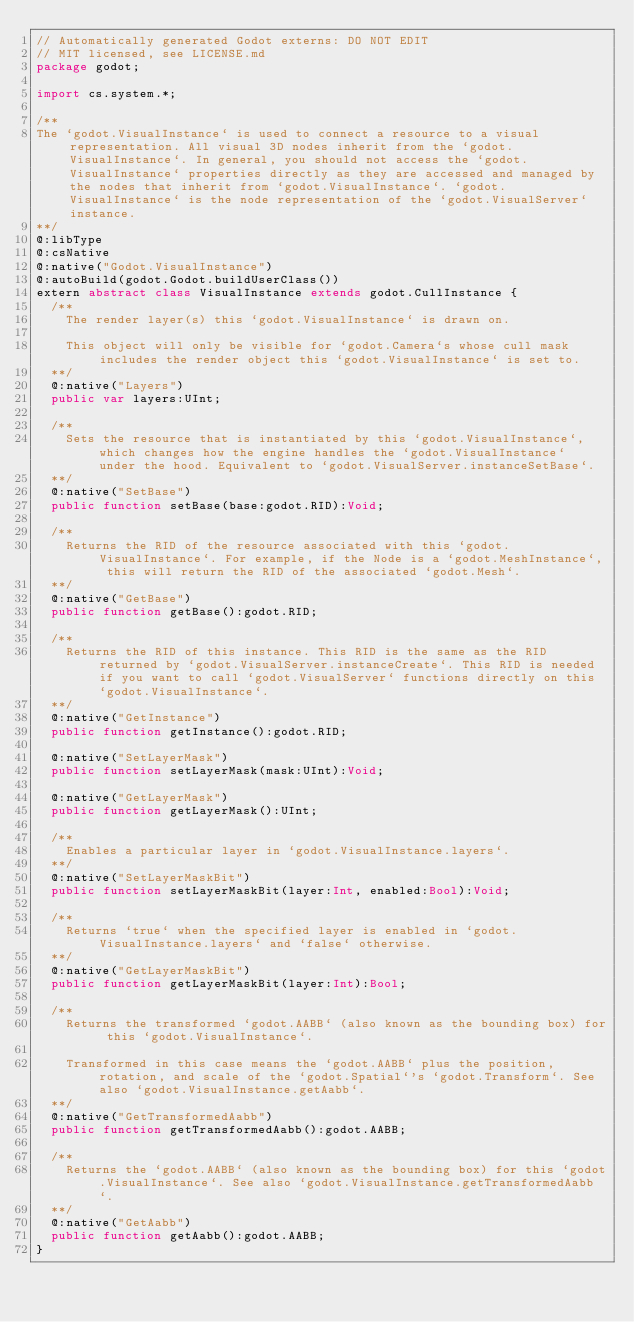Convert code to text. <code><loc_0><loc_0><loc_500><loc_500><_Haxe_>// Automatically generated Godot externs: DO NOT EDIT
// MIT licensed, see LICENSE.md
package godot;

import cs.system.*;

/**
The `godot.VisualInstance` is used to connect a resource to a visual representation. All visual 3D nodes inherit from the `godot.VisualInstance`. In general, you should not access the `godot.VisualInstance` properties directly as they are accessed and managed by the nodes that inherit from `godot.VisualInstance`. `godot.VisualInstance` is the node representation of the `godot.VisualServer` instance.
**/
@:libType
@:csNative
@:native("Godot.VisualInstance")
@:autoBuild(godot.Godot.buildUserClass())
extern abstract class VisualInstance extends godot.CullInstance {
	/**		
		The render layer(s) this `godot.VisualInstance` is drawn on.
		
		This object will only be visible for `godot.Camera`s whose cull mask includes the render object this `godot.VisualInstance` is set to.
	**/
	@:native("Layers")
	public var layers:UInt;

	/**		
		Sets the resource that is instantiated by this `godot.VisualInstance`, which changes how the engine handles the `godot.VisualInstance` under the hood. Equivalent to `godot.VisualServer.instanceSetBase`.
	**/
	@:native("SetBase")
	public function setBase(base:godot.RID):Void;

	/**		
		Returns the RID of the resource associated with this `godot.VisualInstance`. For example, if the Node is a `godot.MeshInstance`, this will return the RID of the associated `godot.Mesh`.
	**/
	@:native("GetBase")
	public function getBase():godot.RID;

	/**		
		Returns the RID of this instance. This RID is the same as the RID returned by `godot.VisualServer.instanceCreate`. This RID is needed if you want to call `godot.VisualServer` functions directly on this `godot.VisualInstance`.
	**/
	@:native("GetInstance")
	public function getInstance():godot.RID;

	@:native("SetLayerMask")
	public function setLayerMask(mask:UInt):Void;

	@:native("GetLayerMask")
	public function getLayerMask():UInt;

	/**		
		Enables a particular layer in `godot.VisualInstance.layers`.
	**/
	@:native("SetLayerMaskBit")
	public function setLayerMaskBit(layer:Int, enabled:Bool):Void;

	/**		
		Returns `true` when the specified layer is enabled in `godot.VisualInstance.layers` and `false` otherwise.
	**/
	@:native("GetLayerMaskBit")
	public function getLayerMaskBit(layer:Int):Bool;

	/**		
		Returns the transformed `godot.AABB` (also known as the bounding box) for this `godot.VisualInstance`.
		
		Transformed in this case means the `godot.AABB` plus the position, rotation, and scale of the `godot.Spatial`'s `godot.Transform`. See also `godot.VisualInstance.getAabb`.
	**/
	@:native("GetTransformedAabb")
	public function getTransformedAabb():godot.AABB;

	/**		
		Returns the `godot.AABB` (also known as the bounding box) for this `godot.VisualInstance`. See also `godot.VisualInstance.getTransformedAabb`.
	**/
	@:native("GetAabb")
	public function getAabb():godot.AABB;
}
</code> 